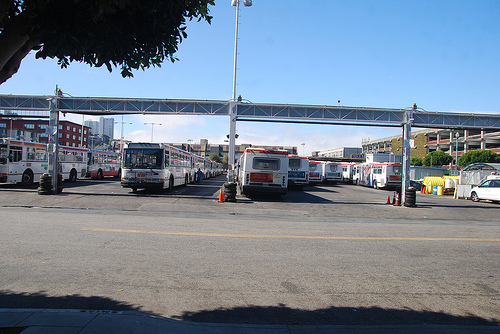Are there any buses? Absolutely, there are multiple buses lined up in the parking lot, indicating either a transit hub or a bus depot. 